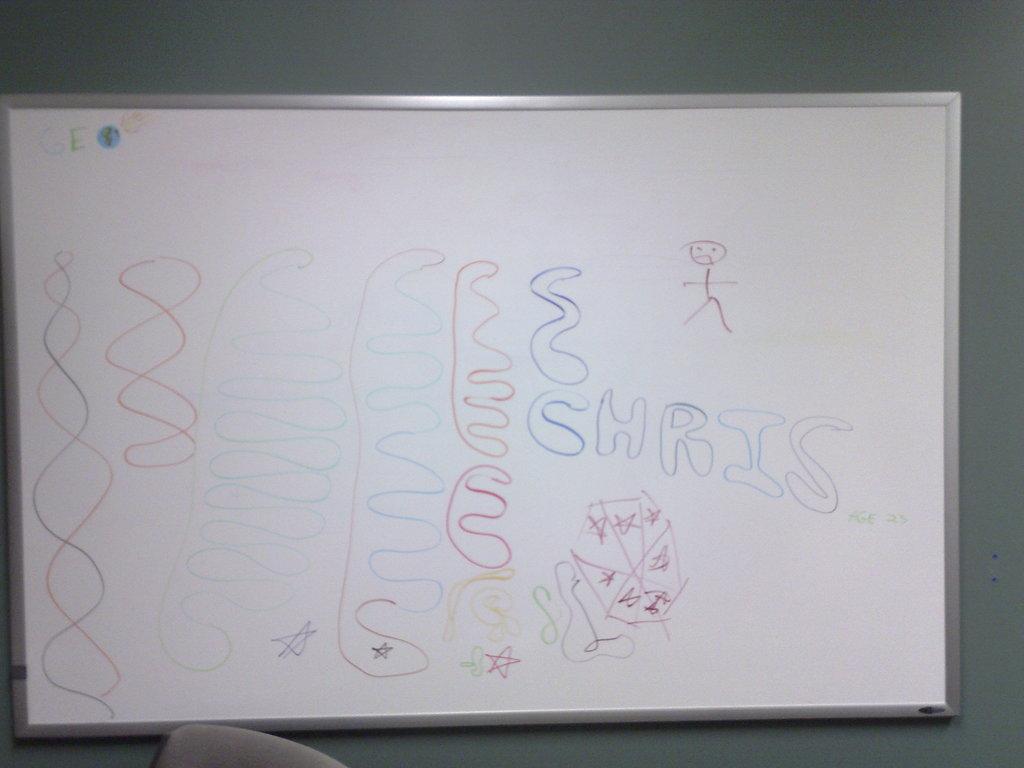What is the name written on the board?
Make the answer very short. Chris. What initials are written in the top left corner?
Your response must be concise. Ge. 